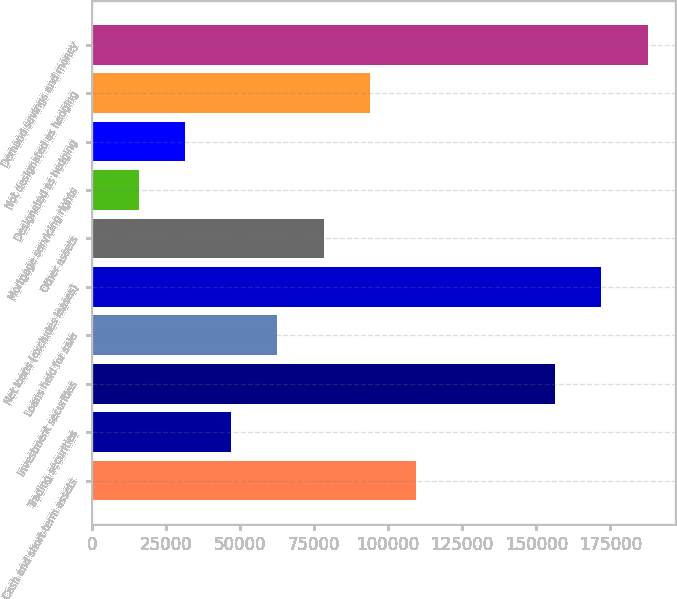Convert chart. <chart><loc_0><loc_0><loc_500><loc_500><bar_chart><fcel>Cash and short-term assets<fcel>Trading securities<fcel>Investment securities<fcel>Loans held for sale<fcel>Net loans (excludes leases)<fcel>Other assets<fcel>Mortgage servicing rights<fcel>Designated as hedging<fcel>Not designated as hedging<fcel>Demand savings and money<nl><fcel>109501<fcel>47056.6<fcel>156335<fcel>62667.8<fcel>171946<fcel>78279<fcel>15834.2<fcel>31445.4<fcel>93890.2<fcel>187557<nl></chart> 